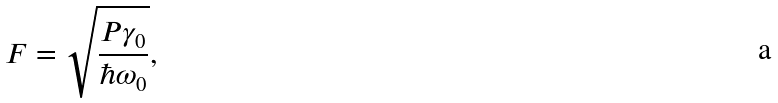Convert formula to latex. <formula><loc_0><loc_0><loc_500><loc_500>F = \sqrt { \frac { P \gamma _ { 0 } } { \hbar { \omega } _ { 0 } } } ,</formula> 